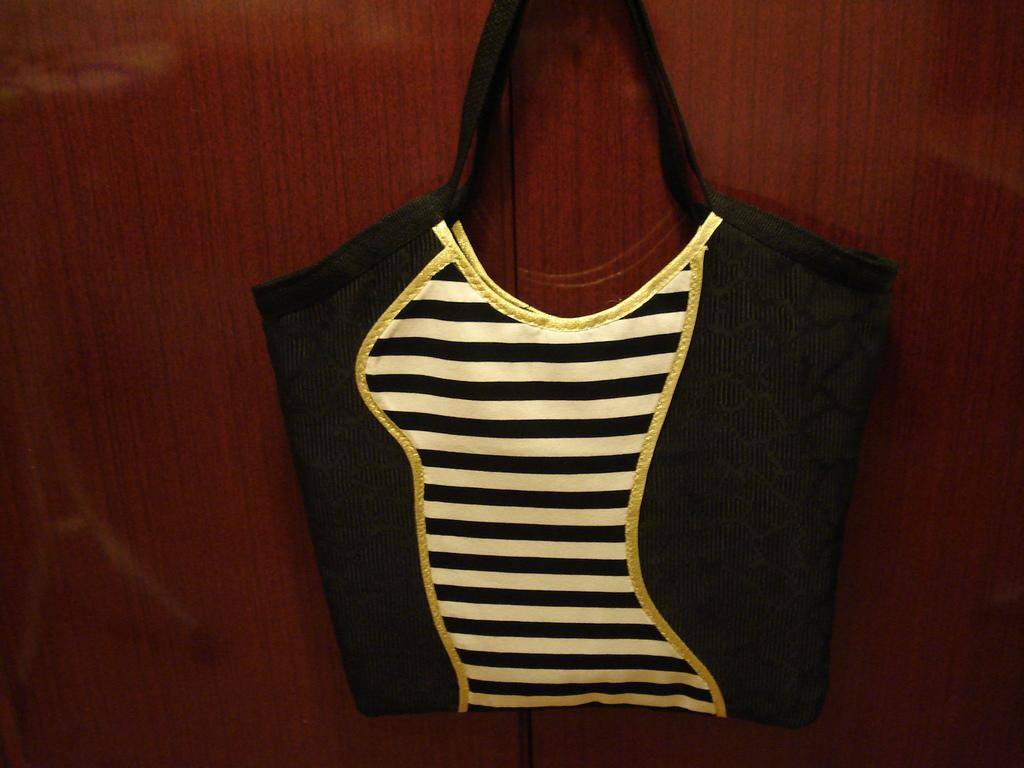What is present in the image that can hold items? There is a bag in the image. Where is the bag located in the image? The bag is hanged on the wall. How can you describe the appearance of the bag? The bag has black and white lines with some design. Is the bag's sister present in the image? There is no mention of a sister or any other person in the image, only the bag. 